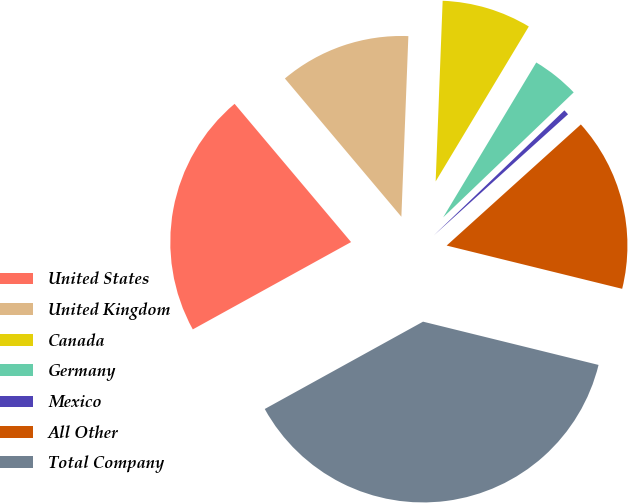Convert chart to OTSL. <chart><loc_0><loc_0><loc_500><loc_500><pie_chart><fcel>United States<fcel>United Kingdom<fcel>Canada<fcel>Germany<fcel>Mexico<fcel>All Other<fcel>Total Company<nl><fcel>21.88%<fcel>11.76%<fcel>8.0%<fcel>4.23%<fcel>0.47%<fcel>15.53%<fcel>38.13%<nl></chart> 